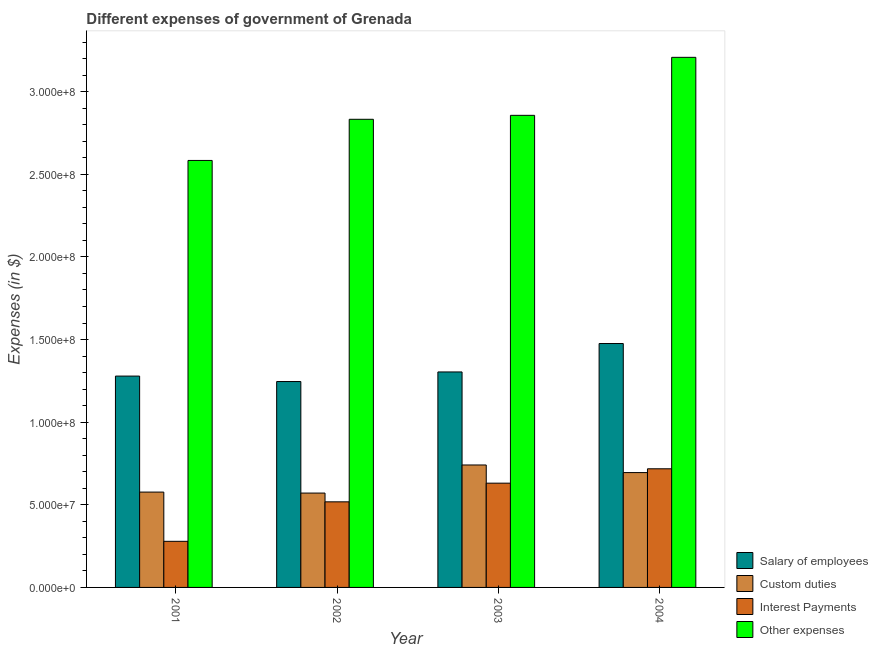How many groups of bars are there?
Ensure brevity in your answer.  4. How many bars are there on the 3rd tick from the left?
Ensure brevity in your answer.  4. How many bars are there on the 3rd tick from the right?
Offer a very short reply. 4. What is the label of the 3rd group of bars from the left?
Keep it short and to the point. 2003. In how many cases, is the number of bars for a given year not equal to the number of legend labels?
Your answer should be very brief. 0. What is the amount spent on interest payments in 2003?
Give a very brief answer. 6.31e+07. Across all years, what is the maximum amount spent on interest payments?
Ensure brevity in your answer.  7.18e+07. Across all years, what is the minimum amount spent on custom duties?
Make the answer very short. 5.71e+07. In which year was the amount spent on other expenses maximum?
Give a very brief answer. 2004. In which year was the amount spent on custom duties minimum?
Provide a short and direct response. 2002. What is the total amount spent on custom duties in the graph?
Provide a short and direct response. 2.58e+08. What is the difference between the amount spent on salary of employees in 2003 and that in 2004?
Give a very brief answer. -1.72e+07. What is the difference between the amount spent on custom duties in 2004 and the amount spent on salary of employees in 2003?
Provide a succinct answer. -4.60e+06. What is the average amount spent on interest payments per year?
Your answer should be very brief. 5.36e+07. In the year 2001, what is the difference between the amount spent on interest payments and amount spent on custom duties?
Give a very brief answer. 0. In how many years, is the amount spent on custom duties greater than 10000000 $?
Your answer should be compact. 4. What is the ratio of the amount spent on interest payments in 2003 to that in 2004?
Provide a succinct answer. 0.88. Is the amount spent on salary of employees in 2002 less than that in 2003?
Offer a very short reply. Yes. What is the difference between the highest and the second highest amount spent on interest payments?
Ensure brevity in your answer.  8.70e+06. What is the difference between the highest and the lowest amount spent on custom duties?
Make the answer very short. 1.70e+07. In how many years, is the amount spent on salary of employees greater than the average amount spent on salary of employees taken over all years?
Provide a succinct answer. 1. Is it the case that in every year, the sum of the amount spent on interest payments and amount spent on salary of employees is greater than the sum of amount spent on custom duties and amount spent on other expenses?
Give a very brief answer. No. What does the 4th bar from the left in 2001 represents?
Offer a very short reply. Other expenses. What does the 1st bar from the right in 2004 represents?
Offer a terse response. Other expenses. Are all the bars in the graph horizontal?
Provide a short and direct response. No. How many years are there in the graph?
Offer a very short reply. 4. Are the values on the major ticks of Y-axis written in scientific E-notation?
Offer a terse response. Yes. Does the graph contain any zero values?
Give a very brief answer. No. Does the graph contain grids?
Ensure brevity in your answer.  No. Where does the legend appear in the graph?
Your answer should be compact. Bottom right. How many legend labels are there?
Ensure brevity in your answer.  4. How are the legend labels stacked?
Ensure brevity in your answer.  Vertical. What is the title of the graph?
Offer a terse response. Different expenses of government of Grenada. Does "Third 20% of population" appear as one of the legend labels in the graph?
Give a very brief answer. No. What is the label or title of the Y-axis?
Provide a short and direct response. Expenses (in $). What is the Expenses (in $) in Salary of employees in 2001?
Make the answer very short. 1.28e+08. What is the Expenses (in $) in Custom duties in 2001?
Your answer should be compact. 5.77e+07. What is the Expenses (in $) of Interest Payments in 2001?
Give a very brief answer. 2.79e+07. What is the Expenses (in $) of Other expenses in 2001?
Keep it short and to the point. 2.58e+08. What is the Expenses (in $) of Salary of employees in 2002?
Give a very brief answer. 1.25e+08. What is the Expenses (in $) of Custom duties in 2002?
Your answer should be very brief. 5.71e+07. What is the Expenses (in $) of Interest Payments in 2002?
Keep it short and to the point. 5.18e+07. What is the Expenses (in $) in Other expenses in 2002?
Make the answer very short. 2.83e+08. What is the Expenses (in $) of Salary of employees in 2003?
Provide a short and direct response. 1.30e+08. What is the Expenses (in $) of Custom duties in 2003?
Offer a terse response. 7.41e+07. What is the Expenses (in $) of Interest Payments in 2003?
Offer a terse response. 6.31e+07. What is the Expenses (in $) of Other expenses in 2003?
Ensure brevity in your answer.  2.86e+08. What is the Expenses (in $) of Salary of employees in 2004?
Ensure brevity in your answer.  1.48e+08. What is the Expenses (in $) of Custom duties in 2004?
Ensure brevity in your answer.  6.95e+07. What is the Expenses (in $) in Interest Payments in 2004?
Make the answer very short. 7.18e+07. What is the Expenses (in $) of Other expenses in 2004?
Provide a short and direct response. 3.21e+08. Across all years, what is the maximum Expenses (in $) in Salary of employees?
Provide a short and direct response. 1.48e+08. Across all years, what is the maximum Expenses (in $) in Custom duties?
Provide a short and direct response. 7.41e+07. Across all years, what is the maximum Expenses (in $) of Interest Payments?
Your answer should be compact. 7.18e+07. Across all years, what is the maximum Expenses (in $) of Other expenses?
Provide a succinct answer. 3.21e+08. Across all years, what is the minimum Expenses (in $) of Salary of employees?
Your response must be concise. 1.25e+08. Across all years, what is the minimum Expenses (in $) in Custom duties?
Provide a succinct answer. 5.71e+07. Across all years, what is the minimum Expenses (in $) of Interest Payments?
Provide a short and direct response. 2.79e+07. Across all years, what is the minimum Expenses (in $) in Other expenses?
Your answer should be very brief. 2.58e+08. What is the total Expenses (in $) of Salary of employees in the graph?
Make the answer very short. 5.30e+08. What is the total Expenses (in $) in Custom duties in the graph?
Ensure brevity in your answer.  2.58e+08. What is the total Expenses (in $) of Interest Payments in the graph?
Ensure brevity in your answer.  2.15e+08. What is the total Expenses (in $) of Other expenses in the graph?
Your response must be concise. 1.15e+09. What is the difference between the Expenses (in $) in Salary of employees in 2001 and that in 2002?
Your answer should be very brief. 3.30e+06. What is the difference between the Expenses (in $) in Interest Payments in 2001 and that in 2002?
Give a very brief answer. -2.39e+07. What is the difference between the Expenses (in $) of Other expenses in 2001 and that in 2002?
Provide a succinct answer. -2.49e+07. What is the difference between the Expenses (in $) in Salary of employees in 2001 and that in 2003?
Offer a very short reply. -2.50e+06. What is the difference between the Expenses (in $) of Custom duties in 2001 and that in 2003?
Provide a short and direct response. -1.64e+07. What is the difference between the Expenses (in $) in Interest Payments in 2001 and that in 2003?
Offer a terse response. -3.52e+07. What is the difference between the Expenses (in $) in Other expenses in 2001 and that in 2003?
Ensure brevity in your answer.  -2.73e+07. What is the difference between the Expenses (in $) in Salary of employees in 2001 and that in 2004?
Give a very brief answer. -1.97e+07. What is the difference between the Expenses (in $) of Custom duties in 2001 and that in 2004?
Your answer should be compact. -1.18e+07. What is the difference between the Expenses (in $) in Interest Payments in 2001 and that in 2004?
Offer a terse response. -4.39e+07. What is the difference between the Expenses (in $) in Other expenses in 2001 and that in 2004?
Your answer should be very brief. -6.24e+07. What is the difference between the Expenses (in $) in Salary of employees in 2002 and that in 2003?
Provide a succinct answer. -5.80e+06. What is the difference between the Expenses (in $) in Custom duties in 2002 and that in 2003?
Offer a very short reply. -1.70e+07. What is the difference between the Expenses (in $) of Interest Payments in 2002 and that in 2003?
Offer a terse response. -1.13e+07. What is the difference between the Expenses (in $) in Other expenses in 2002 and that in 2003?
Your answer should be compact. -2.40e+06. What is the difference between the Expenses (in $) of Salary of employees in 2002 and that in 2004?
Give a very brief answer. -2.30e+07. What is the difference between the Expenses (in $) in Custom duties in 2002 and that in 2004?
Offer a terse response. -1.24e+07. What is the difference between the Expenses (in $) of Interest Payments in 2002 and that in 2004?
Offer a very short reply. -2.00e+07. What is the difference between the Expenses (in $) in Other expenses in 2002 and that in 2004?
Provide a short and direct response. -3.75e+07. What is the difference between the Expenses (in $) in Salary of employees in 2003 and that in 2004?
Make the answer very short. -1.72e+07. What is the difference between the Expenses (in $) in Custom duties in 2003 and that in 2004?
Your answer should be very brief. 4.60e+06. What is the difference between the Expenses (in $) of Interest Payments in 2003 and that in 2004?
Make the answer very short. -8.70e+06. What is the difference between the Expenses (in $) in Other expenses in 2003 and that in 2004?
Give a very brief answer. -3.51e+07. What is the difference between the Expenses (in $) of Salary of employees in 2001 and the Expenses (in $) of Custom duties in 2002?
Offer a terse response. 7.08e+07. What is the difference between the Expenses (in $) of Salary of employees in 2001 and the Expenses (in $) of Interest Payments in 2002?
Make the answer very short. 7.61e+07. What is the difference between the Expenses (in $) in Salary of employees in 2001 and the Expenses (in $) in Other expenses in 2002?
Offer a terse response. -1.55e+08. What is the difference between the Expenses (in $) of Custom duties in 2001 and the Expenses (in $) of Interest Payments in 2002?
Your response must be concise. 5.90e+06. What is the difference between the Expenses (in $) of Custom duties in 2001 and the Expenses (in $) of Other expenses in 2002?
Keep it short and to the point. -2.26e+08. What is the difference between the Expenses (in $) in Interest Payments in 2001 and the Expenses (in $) in Other expenses in 2002?
Your answer should be compact. -2.55e+08. What is the difference between the Expenses (in $) of Salary of employees in 2001 and the Expenses (in $) of Custom duties in 2003?
Provide a short and direct response. 5.38e+07. What is the difference between the Expenses (in $) of Salary of employees in 2001 and the Expenses (in $) of Interest Payments in 2003?
Your answer should be very brief. 6.48e+07. What is the difference between the Expenses (in $) of Salary of employees in 2001 and the Expenses (in $) of Other expenses in 2003?
Ensure brevity in your answer.  -1.58e+08. What is the difference between the Expenses (in $) of Custom duties in 2001 and the Expenses (in $) of Interest Payments in 2003?
Offer a very short reply. -5.40e+06. What is the difference between the Expenses (in $) in Custom duties in 2001 and the Expenses (in $) in Other expenses in 2003?
Provide a succinct answer. -2.28e+08. What is the difference between the Expenses (in $) of Interest Payments in 2001 and the Expenses (in $) of Other expenses in 2003?
Offer a very short reply. -2.58e+08. What is the difference between the Expenses (in $) of Salary of employees in 2001 and the Expenses (in $) of Custom duties in 2004?
Your response must be concise. 5.84e+07. What is the difference between the Expenses (in $) of Salary of employees in 2001 and the Expenses (in $) of Interest Payments in 2004?
Your answer should be very brief. 5.61e+07. What is the difference between the Expenses (in $) in Salary of employees in 2001 and the Expenses (in $) in Other expenses in 2004?
Offer a terse response. -1.93e+08. What is the difference between the Expenses (in $) of Custom duties in 2001 and the Expenses (in $) of Interest Payments in 2004?
Ensure brevity in your answer.  -1.41e+07. What is the difference between the Expenses (in $) in Custom duties in 2001 and the Expenses (in $) in Other expenses in 2004?
Your answer should be compact. -2.63e+08. What is the difference between the Expenses (in $) of Interest Payments in 2001 and the Expenses (in $) of Other expenses in 2004?
Give a very brief answer. -2.93e+08. What is the difference between the Expenses (in $) of Salary of employees in 2002 and the Expenses (in $) of Custom duties in 2003?
Offer a terse response. 5.05e+07. What is the difference between the Expenses (in $) of Salary of employees in 2002 and the Expenses (in $) of Interest Payments in 2003?
Provide a short and direct response. 6.15e+07. What is the difference between the Expenses (in $) in Salary of employees in 2002 and the Expenses (in $) in Other expenses in 2003?
Ensure brevity in your answer.  -1.61e+08. What is the difference between the Expenses (in $) in Custom duties in 2002 and the Expenses (in $) in Interest Payments in 2003?
Give a very brief answer. -6.00e+06. What is the difference between the Expenses (in $) in Custom duties in 2002 and the Expenses (in $) in Other expenses in 2003?
Provide a short and direct response. -2.29e+08. What is the difference between the Expenses (in $) in Interest Payments in 2002 and the Expenses (in $) in Other expenses in 2003?
Make the answer very short. -2.34e+08. What is the difference between the Expenses (in $) of Salary of employees in 2002 and the Expenses (in $) of Custom duties in 2004?
Offer a terse response. 5.51e+07. What is the difference between the Expenses (in $) in Salary of employees in 2002 and the Expenses (in $) in Interest Payments in 2004?
Provide a succinct answer. 5.28e+07. What is the difference between the Expenses (in $) in Salary of employees in 2002 and the Expenses (in $) in Other expenses in 2004?
Ensure brevity in your answer.  -1.96e+08. What is the difference between the Expenses (in $) of Custom duties in 2002 and the Expenses (in $) of Interest Payments in 2004?
Keep it short and to the point. -1.47e+07. What is the difference between the Expenses (in $) of Custom duties in 2002 and the Expenses (in $) of Other expenses in 2004?
Give a very brief answer. -2.64e+08. What is the difference between the Expenses (in $) of Interest Payments in 2002 and the Expenses (in $) of Other expenses in 2004?
Offer a terse response. -2.69e+08. What is the difference between the Expenses (in $) in Salary of employees in 2003 and the Expenses (in $) in Custom duties in 2004?
Your response must be concise. 6.09e+07. What is the difference between the Expenses (in $) in Salary of employees in 2003 and the Expenses (in $) in Interest Payments in 2004?
Ensure brevity in your answer.  5.86e+07. What is the difference between the Expenses (in $) in Salary of employees in 2003 and the Expenses (in $) in Other expenses in 2004?
Make the answer very short. -1.90e+08. What is the difference between the Expenses (in $) of Custom duties in 2003 and the Expenses (in $) of Interest Payments in 2004?
Your response must be concise. 2.30e+06. What is the difference between the Expenses (in $) in Custom duties in 2003 and the Expenses (in $) in Other expenses in 2004?
Provide a succinct answer. -2.47e+08. What is the difference between the Expenses (in $) in Interest Payments in 2003 and the Expenses (in $) in Other expenses in 2004?
Ensure brevity in your answer.  -2.58e+08. What is the average Expenses (in $) of Salary of employees per year?
Your response must be concise. 1.33e+08. What is the average Expenses (in $) of Custom duties per year?
Make the answer very short. 6.46e+07. What is the average Expenses (in $) in Interest Payments per year?
Give a very brief answer. 5.36e+07. What is the average Expenses (in $) of Other expenses per year?
Your answer should be compact. 2.87e+08. In the year 2001, what is the difference between the Expenses (in $) in Salary of employees and Expenses (in $) in Custom duties?
Keep it short and to the point. 7.02e+07. In the year 2001, what is the difference between the Expenses (in $) of Salary of employees and Expenses (in $) of Interest Payments?
Make the answer very short. 1.00e+08. In the year 2001, what is the difference between the Expenses (in $) in Salary of employees and Expenses (in $) in Other expenses?
Offer a terse response. -1.30e+08. In the year 2001, what is the difference between the Expenses (in $) in Custom duties and Expenses (in $) in Interest Payments?
Provide a short and direct response. 2.98e+07. In the year 2001, what is the difference between the Expenses (in $) in Custom duties and Expenses (in $) in Other expenses?
Ensure brevity in your answer.  -2.01e+08. In the year 2001, what is the difference between the Expenses (in $) of Interest Payments and Expenses (in $) of Other expenses?
Make the answer very short. -2.30e+08. In the year 2002, what is the difference between the Expenses (in $) of Salary of employees and Expenses (in $) of Custom duties?
Give a very brief answer. 6.75e+07. In the year 2002, what is the difference between the Expenses (in $) in Salary of employees and Expenses (in $) in Interest Payments?
Your response must be concise. 7.28e+07. In the year 2002, what is the difference between the Expenses (in $) of Salary of employees and Expenses (in $) of Other expenses?
Ensure brevity in your answer.  -1.59e+08. In the year 2002, what is the difference between the Expenses (in $) in Custom duties and Expenses (in $) in Interest Payments?
Offer a terse response. 5.30e+06. In the year 2002, what is the difference between the Expenses (in $) of Custom duties and Expenses (in $) of Other expenses?
Give a very brief answer. -2.26e+08. In the year 2002, what is the difference between the Expenses (in $) of Interest Payments and Expenses (in $) of Other expenses?
Your answer should be compact. -2.32e+08. In the year 2003, what is the difference between the Expenses (in $) in Salary of employees and Expenses (in $) in Custom duties?
Your response must be concise. 5.63e+07. In the year 2003, what is the difference between the Expenses (in $) of Salary of employees and Expenses (in $) of Interest Payments?
Offer a very short reply. 6.73e+07. In the year 2003, what is the difference between the Expenses (in $) in Salary of employees and Expenses (in $) in Other expenses?
Ensure brevity in your answer.  -1.55e+08. In the year 2003, what is the difference between the Expenses (in $) of Custom duties and Expenses (in $) of Interest Payments?
Provide a succinct answer. 1.10e+07. In the year 2003, what is the difference between the Expenses (in $) of Custom duties and Expenses (in $) of Other expenses?
Give a very brief answer. -2.12e+08. In the year 2003, what is the difference between the Expenses (in $) in Interest Payments and Expenses (in $) in Other expenses?
Keep it short and to the point. -2.23e+08. In the year 2004, what is the difference between the Expenses (in $) in Salary of employees and Expenses (in $) in Custom duties?
Keep it short and to the point. 7.81e+07. In the year 2004, what is the difference between the Expenses (in $) in Salary of employees and Expenses (in $) in Interest Payments?
Your response must be concise. 7.58e+07. In the year 2004, what is the difference between the Expenses (in $) in Salary of employees and Expenses (in $) in Other expenses?
Keep it short and to the point. -1.73e+08. In the year 2004, what is the difference between the Expenses (in $) in Custom duties and Expenses (in $) in Interest Payments?
Keep it short and to the point. -2.30e+06. In the year 2004, what is the difference between the Expenses (in $) of Custom duties and Expenses (in $) of Other expenses?
Offer a very short reply. -2.51e+08. In the year 2004, what is the difference between the Expenses (in $) in Interest Payments and Expenses (in $) in Other expenses?
Provide a succinct answer. -2.49e+08. What is the ratio of the Expenses (in $) in Salary of employees in 2001 to that in 2002?
Provide a succinct answer. 1.03. What is the ratio of the Expenses (in $) of Custom duties in 2001 to that in 2002?
Give a very brief answer. 1.01. What is the ratio of the Expenses (in $) in Interest Payments in 2001 to that in 2002?
Keep it short and to the point. 0.54. What is the ratio of the Expenses (in $) of Other expenses in 2001 to that in 2002?
Offer a very short reply. 0.91. What is the ratio of the Expenses (in $) of Salary of employees in 2001 to that in 2003?
Keep it short and to the point. 0.98. What is the ratio of the Expenses (in $) in Custom duties in 2001 to that in 2003?
Ensure brevity in your answer.  0.78. What is the ratio of the Expenses (in $) in Interest Payments in 2001 to that in 2003?
Your response must be concise. 0.44. What is the ratio of the Expenses (in $) of Other expenses in 2001 to that in 2003?
Your answer should be compact. 0.9. What is the ratio of the Expenses (in $) in Salary of employees in 2001 to that in 2004?
Your answer should be very brief. 0.87. What is the ratio of the Expenses (in $) of Custom duties in 2001 to that in 2004?
Ensure brevity in your answer.  0.83. What is the ratio of the Expenses (in $) of Interest Payments in 2001 to that in 2004?
Give a very brief answer. 0.39. What is the ratio of the Expenses (in $) of Other expenses in 2001 to that in 2004?
Offer a terse response. 0.81. What is the ratio of the Expenses (in $) of Salary of employees in 2002 to that in 2003?
Provide a short and direct response. 0.96. What is the ratio of the Expenses (in $) of Custom duties in 2002 to that in 2003?
Keep it short and to the point. 0.77. What is the ratio of the Expenses (in $) in Interest Payments in 2002 to that in 2003?
Your response must be concise. 0.82. What is the ratio of the Expenses (in $) in Other expenses in 2002 to that in 2003?
Your answer should be very brief. 0.99. What is the ratio of the Expenses (in $) of Salary of employees in 2002 to that in 2004?
Ensure brevity in your answer.  0.84. What is the ratio of the Expenses (in $) of Custom duties in 2002 to that in 2004?
Keep it short and to the point. 0.82. What is the ratio of the Expenses (in $) in Interest Payments in 2002 to that in 2004?
Offer a terse response. 0.72. What is the ratio of the Expenses (in $) in Other expenses in 2002 to that in 2004?
Your answer should be very brief. 0.88. What is the ratio of the Expenses (in $) in Salary of employees in 2003 to that in 2004?
Your answer should be compact. 0.88. What is the ratio of the Expenses (in $) of Custom duties in 2003 to that in 2004?
Give a very brief answer. 1.07. What is the ratio of the Expenses (in $) of Interest Payments in 2003 to that in 2004?
Ensure brevity in your answer.  0.88. What is the ratio of the Expenses (in $) in Other expenses in 2003 to that in 2004?
Provide a succinct answer. 0.89. What is the difference between the highest and the second highest Expenses (in $) in Salary of employees?
Keep it short and to the point. 1.72e+07. What is the difference between the highest and the second highest Expenses (in $) of Custom duties?
Keep it short and to the point. 4.60e+06. What is the difference between the highest and the second highest Expenses (in $) of Interest Payments?
Provide a short and direct response. 8.70e+06. What is the difference between the highest and the second highest Expenses (in $) in Other expenses?
Give a very brief answer. 3.51e+07. What is the difference between the highest and the lowest Expenses (in $) of Salary of employees?
Your answer should be very brief. 2.30e+07. What is the difference between the highest and the lowest Expenses (in $) in Custom duties?
Ensure brevity in your answer.  1.70e+07. What is the difference between the highest and the lowest Expenses (in $) of Interest Payments?
Your answer should be very brief. 4.39e+07. What is the difference between the highest and the lowest Expenses (in $) of Other expenses?
Ensure brevity in your answer.  6.24e+07. 